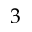Convert formula to latex. <formula><loc_0><loc_0><loc_500><loc_500>3</formula> 